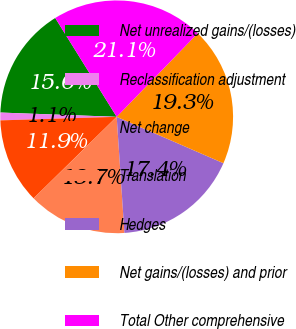Convert chart to OTSL. <chart><loc_0><loc_0><loc_500><loc_500><pie_chart><fcel>Net unrealized gains/(losses)<fcel>Reclassification adjustment<fcel>Net change<fcel>Translation<fcel>Hedges<fcel>Net gains/(losses) and prior<fcel>Total Other comprehensive<nl><fcel>15.56%<fcel>1.07%<fcel>11.86%<fcel>13.71%<fcel>17.41%<fcel>19.26%<fcel>21.11%<nl></chart> 